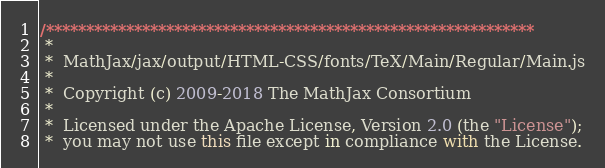Convert code to text. <code><loc_0><loc_0><loc_500><loc_500><_JavaScript_>/*************************************************************
 *
 *  MathJax/jax/output/HTML-CSS/fonts/TeX/Main/Regular/Main.js
 *
 *  Copyright (c) 2009-2018 The MathJax Consortium
 *
 *  Licensed under the Apache License, Version 2.0 (the "License");
 *  you may not use this file except in compliance with the License.</code> 